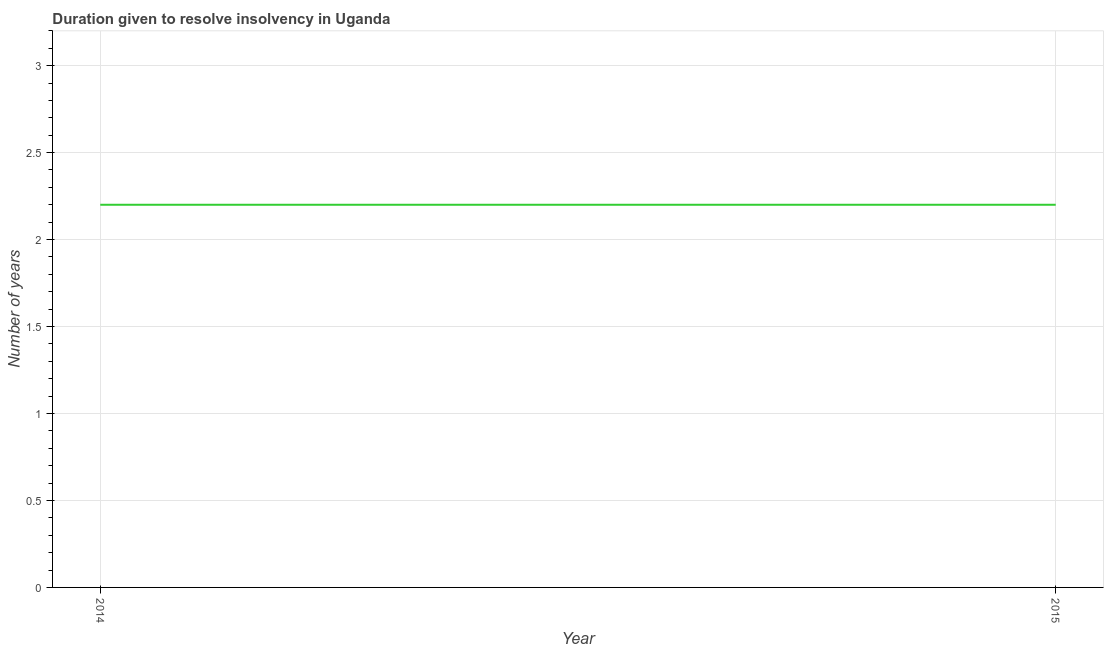In which year was the number of years to resolve insolvency minimum?
Ensure brevity in your answer.  2014. What is the average number of years to resolve insolvency per year?
Make the answer very short. 2.2. What is the median number of years to resolve insolvency?
Offer a terse response. 2.2. What is the ratio of the number of years to resolve insolvency in 2014 to that in 2015?
Provide a succinct answer. 1. Is the number of years to resolve insolvency in 2014 less than that in 2015?
Provide a short and direct response. No. Does the number of years to resolve insolvency monotonically increase over the years?
Offer a terse response. No. How many lines are there?
Ensure brevity in your answer.  1. How many years are there in the graph?
Your answer should be very brief. 2. What is the difference between two consecutive major ticks on the Y-axis?
Provide a succinct answer. 0.5. What is the title of the graph?
Offer a very short reply. Duration given to resolve insolvency in Uganda. What is the label or title of the Y-axis?
Provide a short and direct response. Number of years. What is the Number of years in 2014?
Provide a short and direct response. 2.2. What is the ratio of the Number of years in 2014 to that in 2015?
Provide a succinct answer. 1. 